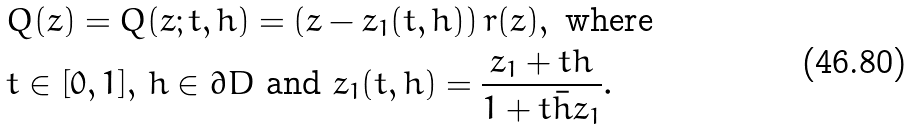<formula> <loc_0><loc_0><loc_500><loc_500>& Q ( z ) = Q ( z ; t , h ) = \left ( z - z _ { 1 } ( t , h ) \right ) r ( z ) , \text { where} \\ & t \in [ 0 , 1 ] , \, h \in \partial D \text { and } z _ { 1 } ( t , h ) = \frac { z _ { 1 } + t h } { 1 + t \bar { h } z _ { 1 } } .</formula> 